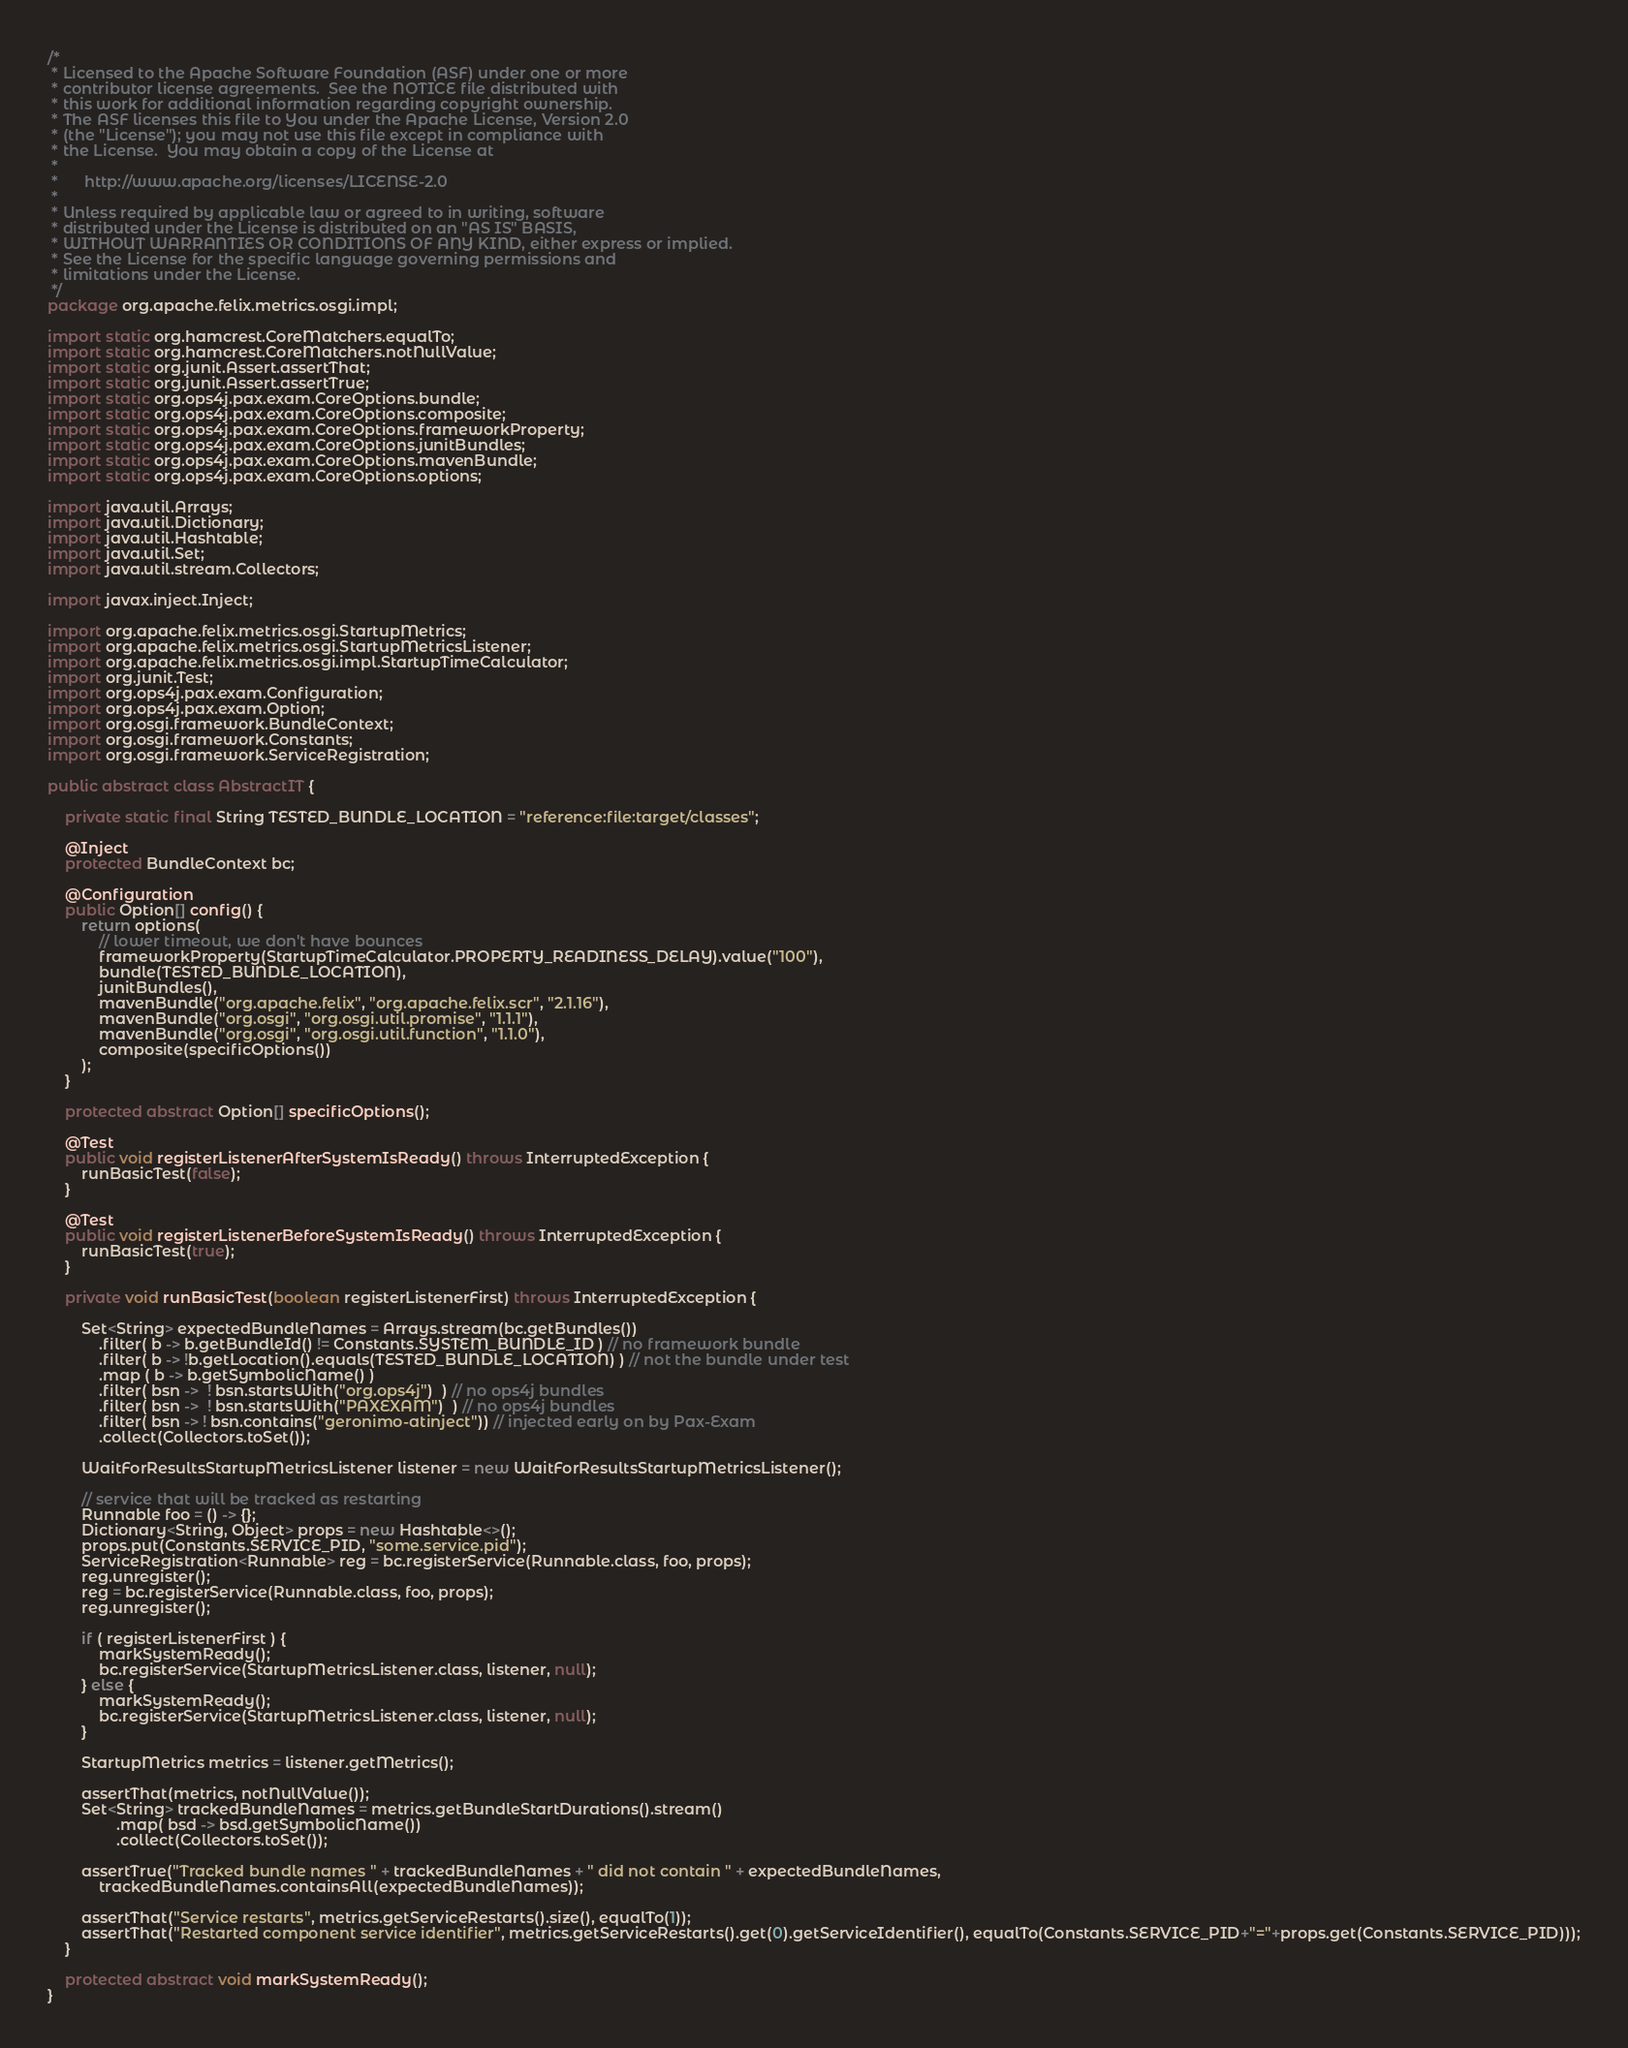<code> <loc_0><loc_0><loc_500><loc_500><_Java_>/*
 * Licensed to the Apache Software Foundation (ASF) under one or more
 * contributor license agreements.  See the NOTICE file distributed with
 * this work for additional information regarding copyright ownership.
 * The ASF licenses this file to You under the Apache License, Version 2.0
 * (the "License"); you may not use this file except in compliance with
 * the License.  You may obtain a copy of the License at
 *
 *      http://www.apache.org/licenses/LICENSE-2.0
 *
 * Unless required by applicable law or agreed to in writing, software
 * distributed under the License is distributed on an "AS IS" BASIS,
 * WITHOUT WARRANTIES OR CONDITIONS OF ANY KIND, either express or implied.
 * See the License for the specific language governing permissions and
 * limitations under the License.
 */
package org.apache.felix.metrics.osgi.impl;

import static org.hamcrest.CoreMatchers.equalTo;
import static org.hamcrest.CoreMatchers.notNullValue;
import static org.junit.Assert.assertThat;
import static org.junit.Assert.assertTrue;
import static org.ops4j.pax.exam.CoreOptions.bundle;
import static org.ops4j.pax.exam.CoreOptions.composite;
import static org.ops4j.pax.exam.CoreOptions.frameworkProperty;
import static org.ops4j.pax.exam.CoreOptions.junitBundles;
import static org.ops4j.pax.exam.CoreOptions.mavenBundle;
import static org.ops4j.pax.exam.CoreOptions.options;

import java.util.Arrays;
import java.util.Dictionary;
import java.util.Hashtable;
import java.util.Set;
import java.util.stream.Collectors;

import javax.inject.Inject;

import org.apache.felix.metrics.osgi.StartupMetrics;
import org.apache.felix.metrics.osgi.StartupMetricsListener;
import org.apache.felix.metrics.osgi.impl.StartupTimeCalculator;
import org.junit.Test;
import org.ops4j.pax.exam.Configuration;
import org.ops4j.pax.exam.Option;
import org.osgi.framework.BundleContext;
import org.osgi.framework.Constants;
import org.osgi.framework.ServiceRegistration;

public abstract class AbstractIT {

    private static final String TESTED_BUNDLE_LOCATION = "reference:file:target/classes";

    @Inject
    protected BundleContext bc;

    @Configuration
    public Option[] config() {
        return options(
            // lower timeout, we don't have bounces
            frameworkProperty(StartupTimeCalculator.PROPERTY_READINESS_DELAY).value("100"),
            bundle(TESTED_BUNDLE_LOCATION),
            junitBundles(),
            mavenBundle("org.apache.felix", "org.apache.felix.scr", "2.1.16"),
            mavenBundle("org.osgi", "org.osgi.util.promise", "1.1.1"),
            mavenBundle("org.osgi", "org.osgi.util.function", "1.1.0"),
            composite(specificOptions())
        );
    }
    
    protected abstract Option[] specificOptions();

    @Test
    public void registerListenerAfterSystemIsReady() throws InterruptedException {
        runBasicTest(false);
    }

    @Test
    public void registerListenerBeforeSystemIsReady() throws InterruptedException {
        runBasicTest(true);
    }

    private void runBasicTest(boolean registerListenerFirst) throws InterruptedException {
        
        Set<String> expectedBundleNames = Arrays.stream(bc.getBundles())
            .filter( b -> b.getBundleId() != Constants.SYSTEM_BUNDLE_ID ) // no framework bundle
            .filter( b -> !b.getLocation().equals(TESTED_BUNDLE_LOCATION) ) // not the bundle under test
            .map ( b -> b.getSymbolicName() )
            .filter( bsn ->  ! bsn.startsWith("org.ops4j")  ) // no ops4j bundles
            .filter( bsn ->  ! bsn.startsWith("PAXEXAM")  ) // no ops4j bundles
            .filter( bsn -> ! bsn.contains("geronimo-atinject")) // injected early on by Pax-Exam
            .collect(Collectors.toSet());
        
        WaitForResultsStartupMetricsListener listener = new WaitForResultsStartupMetricsListener();

        // service that will be tracked as restarting
        Runnable foo = () -> {};
        Dictionary<String, Object> props = new Hashtable<>();
        props.put(Constants.SERVICE_PID, "some.service.pid");
        ServiceRegistration<Runnable> reg = bc.registerService(Runnable.class, foo, props);
        reg.unregister();
        reg = bc.registerService(Runnable.class, foo, props);
        reg.unregister();

        if ( registerListenerFirst ) {
            markSystemReady();
            bc.registerService(StartupMetricsListener.class, listener, null);
        } else {
            markSystemReady();
            bc.registerService(StartupMetricsListener.class, listener, null);
        }
        
        StartupMetrics metrics = listener.getMetrics();
        
        assertThat(metrics, notNullValue());
        Set<String> trackedBundleNames = metrics.getBundleStartDurations().stream()
                .map( bsd -> bsd.getSymbolicName())
                .collect(Collectors.toSet());
        
        assertTrue("Tracked bundle names " + trackedBundleNames + " did not contain " + expectedBundleNames, 
            trackedBundleNames.containsAll(expectedBundleNames));
        
        assertThat("Service restarts", metrics.getServiceRestarts().size(), equalTo(1));
        assertThat("Restarted component service identifier", metrics.getServiceRestarts().get(0).getServiceIdentifier(), equalTo(Constants.SERVICE_PID+"="+props.get(Constants.SERVICE_PID)));
    }

    protected abstract void markSystemReady();
}
</code> 